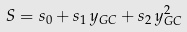Convert formula to latex. <formula><loc_0><loc_0><loc_500><loc_500>S = s _ { 0 } + s _ { 1 } \, y _ { G C } + s _ { 2 } \, y _ { G C } ^ { 2 }</formula> 